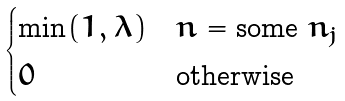Convert formula to latex. <formula><loc_0><loc_0><loc_500><loc_500>\begin{cases} \min ( 1 , \lambda ) & n = \text {some } n _ { j } \\ 0 & \text {otherwise} \end{cases}</formula> 